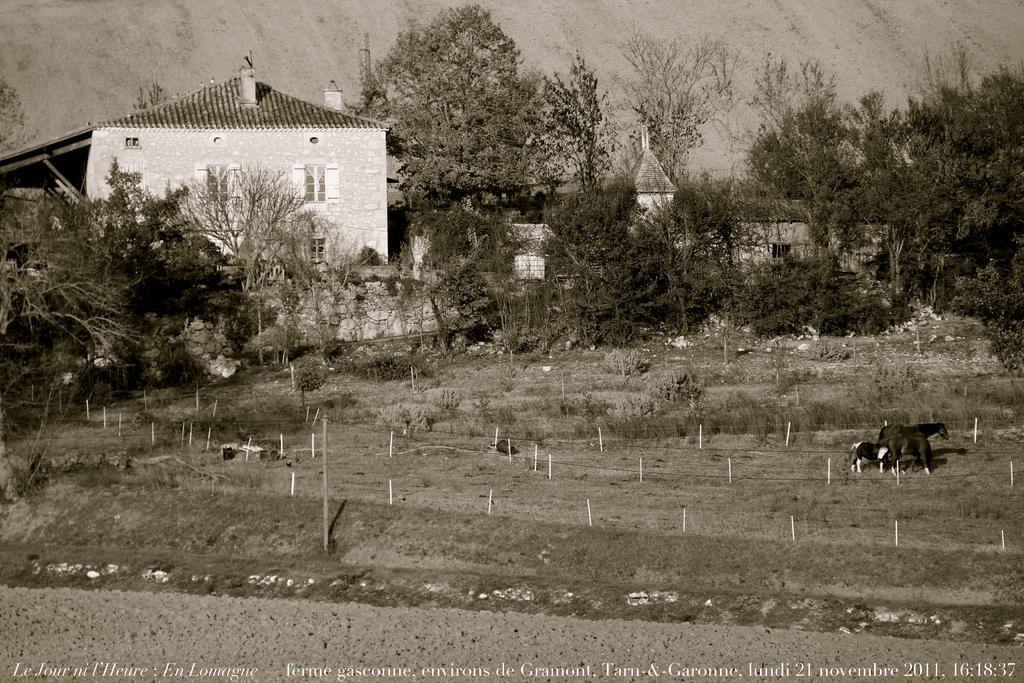Could you give a brief overview of what you see in this image? In this black and white picture there are few buildings. Before it there are few trees on the land having few poles. Right side there are few animals on the land. Background there is a hill. 